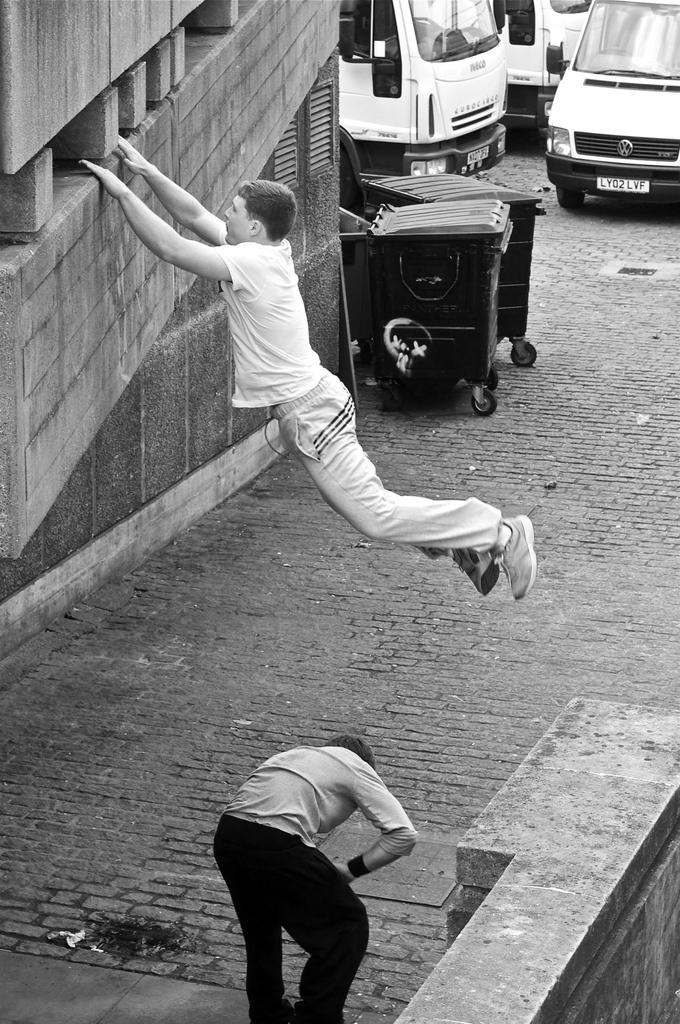What is located in the foreground of the image? There is a fence, two persons, and a building in the foreground of the image. Can you describe the people in the foreground? There are two persons in the foreground of the image. What can be seen in the background of the image? Vehicles and objects on the road are visible in the background of the image. What might be the time of day when the image was taken? The image might have been taken during the day, as there is no indication of darkness or artificial lighting. How many cows are present in the image? There are no cows present in the image. What is the destination of the voyage depicted in the image? There is no voyage depicted in the image. 